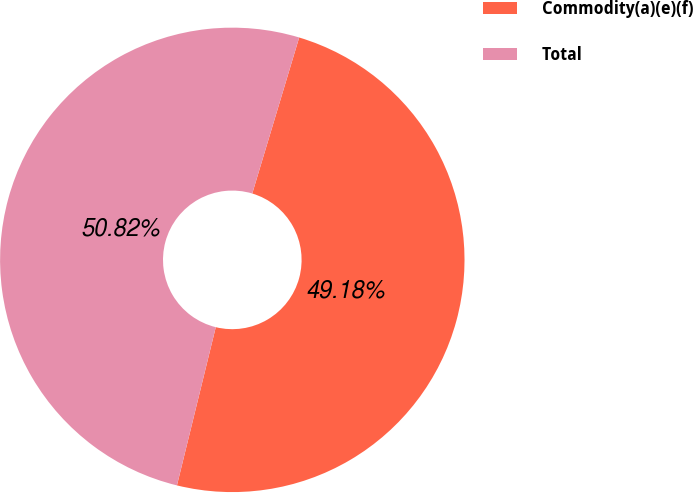<chart> <loc_0><loc_0><loc_500><loc_500><pie_chart><fcel>Commodity(a)(e)(f)<fcel>Total<nl><fcel>49.18%<fcel>50.82%<nl></chart> 